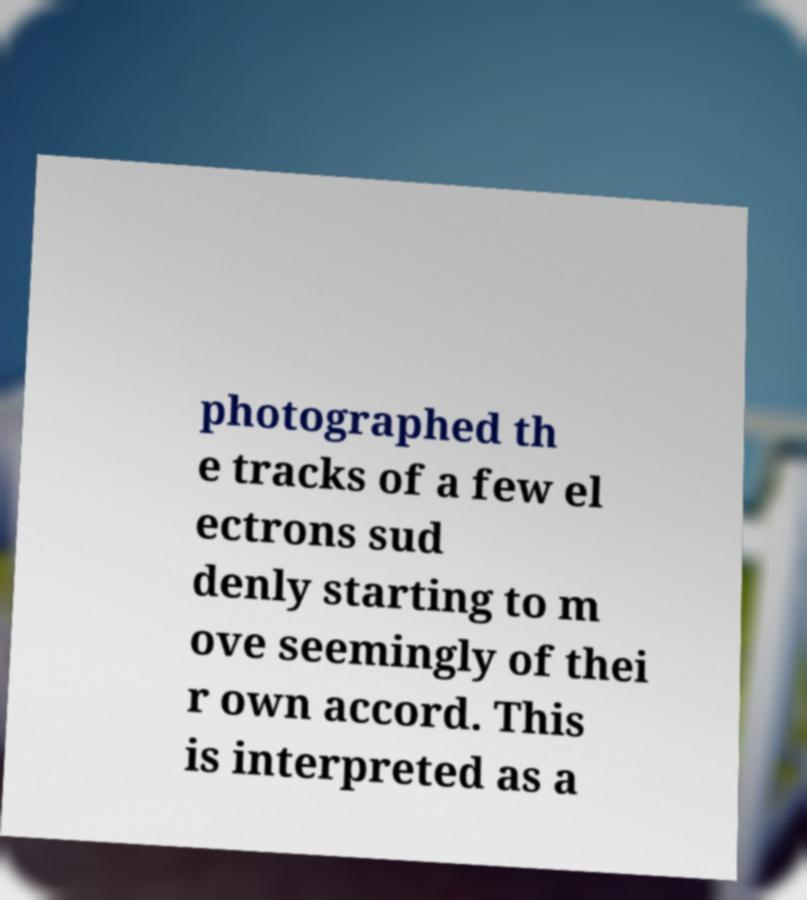Could you assist in decoding the text presented in this image and type it out clearly? photographed th e tracks of a few el ectrons sud denly starting to m ove seemingly of thei r own accord. This is interpreted as a 